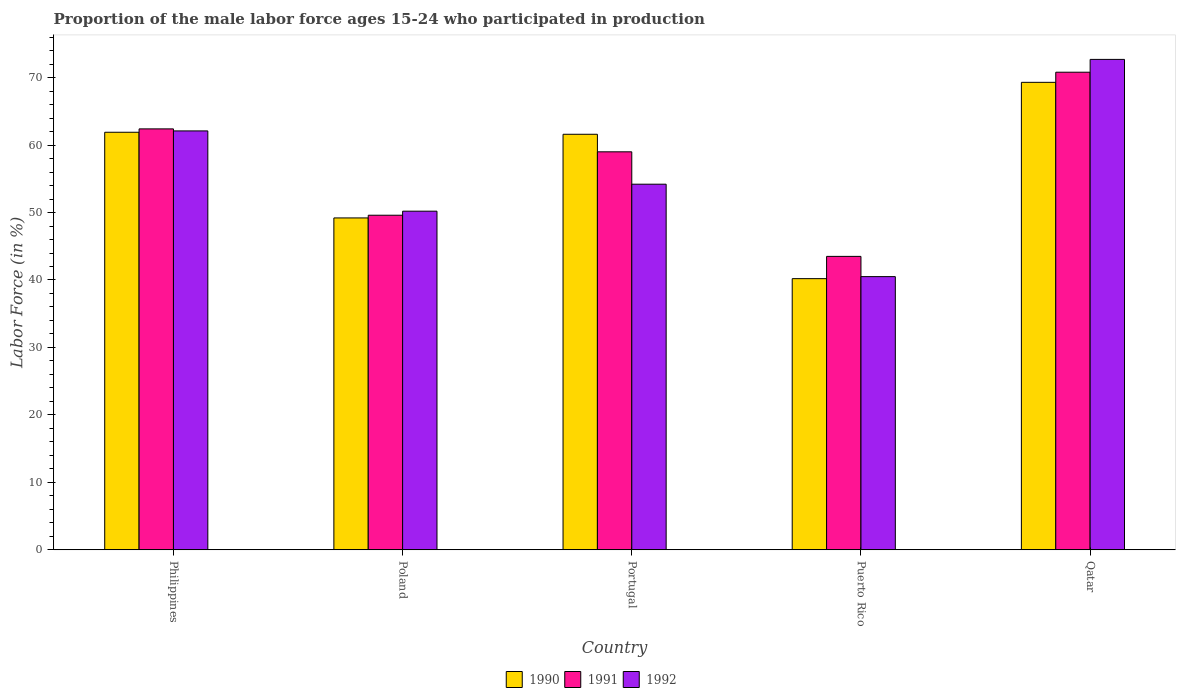How many different coloured bars are there?
Your answer should be compact. 3. How many groups of bars are there?
Offer a very short reply. 5. What is the label of the 5th group of bars from the left?
Provide a succinct answer. Qatar. In how many cases, is the number of bars for a given country not equal to the number of legend labels?
Your response must be concise. 0. What is the proportion of the male labor force who participated in production in 1992 in Portugal?
Your response must be concise. 54.2. Across all countries, what is the maximum proportion of the male labor force who participated in production in 1992?
Your response must be concise. 72.7. Across all countries, what is the minimum proportion of the male labor force who participated in production in 1990?
Offer a terse response. 40.2. In which country was the proportion of the male labor force who participated in production in 1990 maximum?
Ensure brevity in your answer.  Qatar. In which country was the proportion of the male labor force who participated in production in 1992 minimum?
Keep it short and to the point. Puerto Rico. What is the total proportion of the male labor force who participated in production in 1991 in the graph?
Your answer should be compact. 285.3. What is the difference between the proportion of the male labor force who participated in production in 1990 in Poland and that in Portugal?
Make the answer very short. -12.4. What is the difference between the proportion of the male labor force who participated in production in 1990 in Philippines and the proportion of the male labor force who participated in production in 1992 in Qatar?
Provide a short and direct response. -10.8. What is the average proportion of the male labor force who participated in production in 1992 per country?
Provide a short and direct response. 55.94. What is the difference between the proportion of the male labor force who participated in production of/in 1991 and proportion of the male labor force who participated in production of/in 1990 in Portugal?
Your answer should be compact. -2.6. In how many countries, is the proportion of the male labor force who participated in production in 1990 greater than 30 %?
Make the answer very short. 5. What is the ratio of the proportion of the male labor force who participated in production in 1991 in Portugal to that in Puerto Rico?
Provide a succinct answer. 1.36. Is the proportion of the male labor force who participated in production in 1990 in Philippines less than that in Portugal?
Make the answer very short. No. Is the difference between the proportion of the male labor force who participated in production in 1991 in Portugal and Qatar greater than the difference between the proportion of the male labor force who participated in production in 1990 in Portugal and Qatar?
Your answer should be very brief. No. What is the difference between the highest and the second highest proportion of the male labor force who participated in production in 1990?
Your answer should be compact. -0.3. What is the difference between the highest and the lowest proportion of the male labor force who participated in production in 1992?
Offer a terse response. 32.2. Is the sum of the proportion of the male labor force who participated in production in 1990 in Philippines and Qatar greater than the maximum proportion of the male labor force who participated in production in 1992 across all countries?
Give a very brief answer. Yes. What does the 1st bar from the left in Qatar represents?
Give a very brief answer. 1990. What does the 2nd bar from the right in Qatar represents?
Offer a terse response. 1991. Does the graph contain grids?
Provide a succinct answer. No. Where does the legend appear in the graph?
Offer a terse response. Bottom center. How are the legend labels stacked?
Offer a terse response. Horizontal. What is the title of the graph?
Your answer should be compact. Proportion of the male labor force ages 15-24 who participated in production. What is the label or title of the Y-axis?
Keep it short and to the point. Labor Force (in %). What is the Labor Force (in %) of 1990 in Philippines?
Offer a very short reply. 61.9. What is the Labor Force (in %) in 1991 in Philippines?
Provide a short and direct response. 62.4. What is the Labor Force (in %) in 1992 in Philippines?
Make the answer very short. 62.1. What is the Labor Force (in %) of 1990 in Poland?
Your response must be concise. 49.2. What is the Labor Force (in %) in 1991 in Poland?
Ensure brevity in your answer.  49.6. What is the Labor Force (in %) of 1992 in Poland?
Your answer should be compact. 50.2. What is the Labor Force (in %) of 1990 in Portugal?
Offer a very short reply. 61.6. What is the Labor Force (in %) in 1991 in Portugal?
Give a very brief answer. 59. What is the Labor Force (in %) in 1992 in Portugal?
Provide a succinct answer. 54.2. What is the Labor Force (in %) in 1990 in Puerto Rico?
Your response must be concise. 40.2. What is the Labor Force (in %) in 1991 in Puerto Rico?
Make the answer very short. 43.5. What is the Labor Force (in %) in 1992 in Puerto Rico?
Ensure brevity in your answer.  40.5. What is the Labor Force (in %) of 1990 in Qatar?
Ensure brevity in your answer.  69.3. What is the Labor Force (in %) of 1991 in Qatar?
Your answer should be compact. 70.8. What is the Labor Force (in %) in 1992 in Qatar?
Offer a terse response. 72.7. Across all countries, what is the maximum Labor Force (in %) in 1990?
Your answer should be compact. 69.3. Across all countries, what is the maximum Labor Force (in %) of 1991?
Your response must be concise. 70.8. Across all countries, what is the maximum Labor Force (in %) of 1992?
Your answer should be compact. 72.7. Across all countries, what is the minimum Labor Force (in %) in 1990?
Make the answer very short. 40.2. Across all countries, what is the minimum Labor Force (in %) in 1991?
Your answer should be very brief. 43.5. Across all countries, what is the minimum Labor Force (in %) of 1992?
Your response must be concise. 40.5. What is the total Labor Force (in %) of 1990 in the graph?
Give a very brief answer. 282.2. What is the total Labor Force (in %) of 1991 in the graph?
Offer a terse response. 285.3. What is the total Labor Force (in %) of 1992 in the graph?
Your response must be concise. 279.7. What is the difference between the Labor Force (in %) of 1992 in Philippines and that in Poland?
Offer a very short reply. 11.9. What is the difference between the Labor Force (in %) of 1991 in Philippines and that in Portugal?
Your response must be concise. 3.4. What is the difference between the Labor Force (in %) in 1992 in Philippines and that in Portugal?
Offer a terse response. 7.9. What is the difference between the Labor Force (in %) in 1990 in Philippines and that in Puerto Rico?
Give a very brief answer. 21.7. What is the difference between the Labor Force (in %) in 1991 in Philippines and that in Puerto Rico?
Ensure brevity in your answer.  18.9. What is the difference between the Labor Force (in %) in 1992 in Philippines and that in Puerto Rico?
Ensure brevity in your answer.  21.6. What is the difference between the Labor Force (in %) of 1990 in Philippines and that in Qatar?
Offer a very short reply. -7.4. What is the difference between the Labor Force (in %) in 1992 in Philippines and that in Qatar?
Make the answer very short. -10.6. What is the difference between the Labor Force (in %) of 1990 in Poland and that in Portugal?
Offer a very short reply. -12.4. What is the difference between the Labor Force (in %) of 1991 in Poland and that in Portugal?
Offer a very short reply. -9.4. What is the difference between the Labor Force (in %) of 1992 in Poland and that in Portugal?
Offer a terse response. -4. What is the difference between the Labor Force (in %) of 1990 in Poland and that in Puerto Rico?
Give a very brief answer. 9. What is the difference between the Labor Force (in %) of 1991 in Poland and that in Puerto Rico?
Your response must be concise. 6.1. What is the difference between the Labor Force (in %) of 1992 in Poland and that in Puerto Rico?
Offer a terse response. 9.7. What is the difference between the Labor Force (in %) of 1990 in Poland and that in Qatar?
Provide a succinct answer. -20.1. What is the difference between the Labor Force (in %) of 1991 in Poland and that in Qatar?
Offer a terse response. -21.2. What is the difference between the Labor Force (in %) in 1992 in Poland and that in Qatar?
Give a very brief answer. -22.5. What is the difference between the Labor Force (in %) of 1990 in Portugal and that in Puerto Rico?
Provide a short and direct response. 21.4. What is the difference between the Labor Force (in %) in 1992 in Portugal and that in Puerto Rico?
Give a very brief answer. 13.7. What is the difference between the Labor Force (in %) of 1990 in Portugal and that in Qatar?
Give a very brief answer. -7.7. What is the difference between the Labor Force (in %) of 1992 in Portugal and that in Qatar?
Make the answer very short. -18.5. What is the difference between the Labor Force (in %) of 1990 in Puerto Rico and that in Qatar?
Your answer should be compact. -29.1. What is the difference between the Labor Force (in %) in 1991 in Puerto Rico and that in Qatar?
Keep it short and to the point. -27.3. What is the difference between the Labor Force (in %) in 1992 in Puerto Rico and that in Qatar?
Make the answer very short. -32.2. What is the difference between the Labor Force (in %) of 1990 in Philippines and the Labor Force (in %) of 1992 in Poland?
Ensure brevity in your answer.  11.7. What is the difference between the Labor Force (in %) of 1990 in Philippines and the Labor Force (in %) of 1992 in Portugal?
Give a very brief answer. 7.7. What is the difference between the Labor Force (in %) in 1990 in Philippines and the Labor Force (in %) in 1992 in Puerto Rico?
Provide a short and direct response. 21.4. What is the difference between the Labor Force (in %) in 1991 in Philippines and the Labor Force (in %) in 1992 in Puerto Rico?
Offer a very short reply. 21.9. What is the difference between the Labor Force (in %) in 1990 in Philippines and the Labor Force (in %) in 1991 in Qatar?
Your response must be concise. -8.9. What is the difference between the Labor Force (in %) in 1990 in Philippines and the Labor Force (in %) in 1992 in Qatar?
Your answer should be very brief. -10.8. What is the difference between the Labor Force (in %) of 1990 in Poland and the Labor Force (in %) of 1992 in Portugal?
Your answer should be compact. -5. What is the difference between the Labor Force (in %) of 1991 in Poland and the Labor Force (in %) of 1992 in Portugal?
Your response must be concise. -4.6. What is the difference between the Labor Force (in %) in 1990 in Poland and the Labor Force (in %) in 1992 in Puerto Rico?
Keep it short and to the point. 8.7. What is the difference between the Labor Force (in %) of 1990 in Poland and the Labor Force (in %) of 1991 in Qatar?
Your response must be concise. -21.6. What is the difference between the Labor Force (in %) in 1990 in Poland and the Labor Force (in %) in 1992 in Qatar?
Give a very brief answer. -23.5. What is the difference between the Labor Force (in %) in 1991 in Poland and the Labor Force (in %) in 1992 in Qatar?
Ensure brevity in your answer.  -23.1. What is the difference between the Labor Force (in %) in 1990 in Portugal and the Labor Force (in %) in 1992 in Puerto Rico?
Offer a terse response. 21.1. What is the difference between the Labor Force (in %) in 1991 in Portugal and the Labor Force (in %) in 1992 in Qatar?
Make the answer very short. -13.7. What is the difference between the Labor Force (in %) in 1990 in Puerto Rico and the Labor Force (in %) in 1991 in Qatar?
Your answer should be very brief. -30.6. What is the difference between the Labor Force (in %) of 1990 in Puerto Rico and the Labor Force (in %) of 1992 in Qatar?
Provide a short and direct response. -32.5. What is the difference between the Labor Force (in %) in 1991 in Puerto Rico and the Labor Force (in %) in 1992 in Qatar?
Provide a short and direct response. -29.2. What is the average Labor Force (in %) in 1990 per country?
Provide a short and direct response. 56.44. What is the average Labor Force (in %) of 1991 per country?
Ensure brevity in your answer.  57.06. What is the average Labor Force (in %) of 1992 per country?
Make the answer very short. 55.94. What is the difference between the Labor Force (in %) of 1990 and Labor Force (in %) of 1992 in Poland?
Offer a very short reply. -1. What is the difference between the Labor Force (in %) of 1991 and Labor Force (in %) of 1992 in Poland?
Give a very brief answer. -0.6. What is the difference between the Labor Force (in %) of 1991 and Labor Force (in %) of 1992 in Portugal?
Ensure brevity in your answer.  4.8. What is the difference between the Labor Force (in %) in 1991 and Labor Force (in %) in 1992 in Puerto Rico?
Keep it short and to the point. 3. What is the difference between the Labor Force (in %) in 1991 and Labor Force (in %) in 1992 in Qatar?
Offer a terse response. -1.9. What is the ratio of the Labor Force (in %) in 1990 in Philippines to that in Poland?
Give a very brief answer. 1.26. What is the ratio of the Labor Force (in %) of 1991 in Philippines to that in Poland?
Provide a short and direct response. 1.26. What is the ratio of the Labor Force (in %) of 1992 in Philippines to that in Poland?
Provide a short and direct response. 1.24. What is the ratio of the Labor Force (in %) of 1991 in Philippines to that in Portugal?
Keep it short and to the point. 1.06. What is the ratio of the Labor Force (in %) of 1992 in Philippines to that in Portugal?
Make the answer very short. 1.15. What is the ratio of the Labor Force (in %) in 1990 in Philippines to that in Puerto Rico?
Make the answer very short. 1.54. What is the ratio of the Labor Force (in %) of 1991 in Philippines to that in Puerto Rico?
Your answer should be compact. 1.43. What is the ratio of the Labor Force (in %) of 1992 in Philippines to that in Puerto Rico?
Offer a terse response. 1.53. What is the ratio of the Labor Force (in %) of 1990 in Philippines to that in Qatar?
Make the answer very short. 0.89. What is the ratio of the Labor Force (in %) in 1991 in Philippines to that in Qatar?
Provide a short and direct response. 0.88. What is the ratio of the Labor Force (in %) in 1992 in Philippines to that in Qatar?
Your answer should be compact. 0.85. What is the ratio of the Labor Force (in %) in 1990 in Poland to that in Portugal?
Your response must be concise. 0.8. What is the ratio of the Labor Force (in %) in 1991 in Poland to that in Portugal?
Your answer should be very brief. 0.84. What is the ratio of the Labor Force (in %) of 1992 in Poland to that in Portugal?
Your response must be concise. 0.93. What is the ratio of the Labor Force (in %) of 1990 in Poland to that in Puerto Rico?
Provide a succinct answer. 1.22. What is the ratio of the Labor Force (in %) in 1991 in Poland to that in Puerto Rico?
Your answer should be very brief. 1.14. What is the ratio of the Labor Force (in %) in 1992 in Poland to that in Puerto Rico?
Your answer should be compact. 1.24. What is the ratio of the Labor Force (in %) of 1990 in Poland to that in Qatar?
Offer a terse response. 0.71. What is the ratio of the Labor Force (in %) of 1991 in Poland to that in Qatar?
Offer a very short reply. 0.7. What is the ratio of the Labor Force (in %) in 1992 in Poland to that in Qatar?
Ensure brevity in your answer.  0.69. What is the ratio of the Labor Force (in %) in 1990 in Portugal to that in Puerto Rico?
Keep it short and to the point. 1.53. What is the ratio of the Labor Force (in %) in 1991 in Portugal to that in Puerto Rico?
Your response must be concise. 1.36. What is the ratio of the Labor Force (in %) of 1992 in Portugal to that in Puerto Rico?
Your answer should be compact. 1.34. What is the ratio of the Labor Force (in %) of 1990 in Portugal to that in Qatar?
Offer a terse response. 0.89. What is the ratio of the Labor Force (in %) of 1992 in Portugal to that in Qatar?
Ensure brevity in your answer.  0.75. What is the ratio of the Labor Force (in %) in 1990 in Puerto Rico to that in Qatar?
Your answer should be compact. 0.58. What is the ratio of the Labor Force (in %) in 1991 in Puerto Rico to that in Qatar?
Keep it short and to the point. 0.61. What is the ratio of the Labor Force (in %) of 1992 in Puerto Rico to that in Qatar?
Your answer should be very brief. 0.56. What is the difference between the highest and the second highest Labor Force (in %) of 1990?
Provide a short and direct response. 7.4. What is the difference between the highest and the second highest Labor Force (in %) of 1991?
Ensure brevity in your answer.  8.4. What is the difference between the highest and the second highest Labor Force (in %) in 1992?
Provide a short and direct response. 10.6. What is the difference between the highest and the lowest Labor Force (in %) of 1990?
Offer a terse response. 29.1. What is the difference between the highest and the lowest Labor Force (in %) of 1991?
Your response must be concise. 27.3. What is the difference between the highest and the lowest Labor Force (in %) of 1992?
Ensure brevity in your answer.  32.2. 